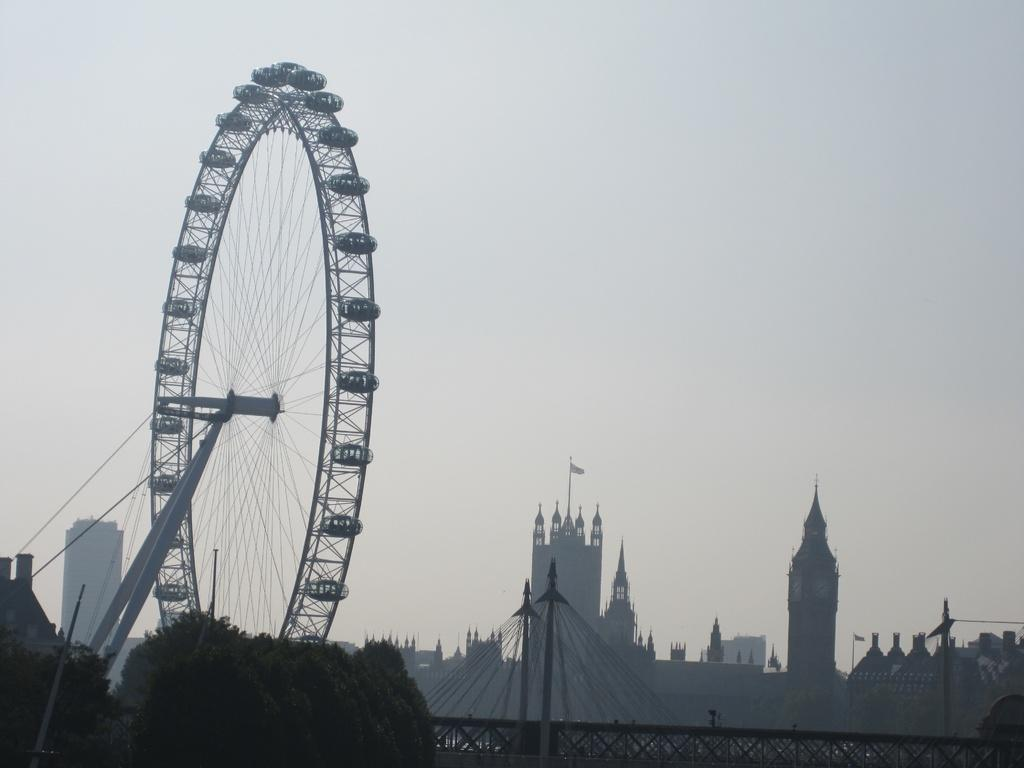What is the main feature in the image? There is a giant wheel in the image. What can be seen surrounding the giant wheel? There are buildings around the giant wheel. What type of vegetation is visible in the foreground of the image? There are trees in the foreground of the image. How many clocks are hanging from the giant wheel in the image? There are no clocks hanging from the giant wheel in the image. What type of horn can be heard coming from the buildings in the image? There is no sound or horn present in the image, so it cannot be determined what might be heard. 